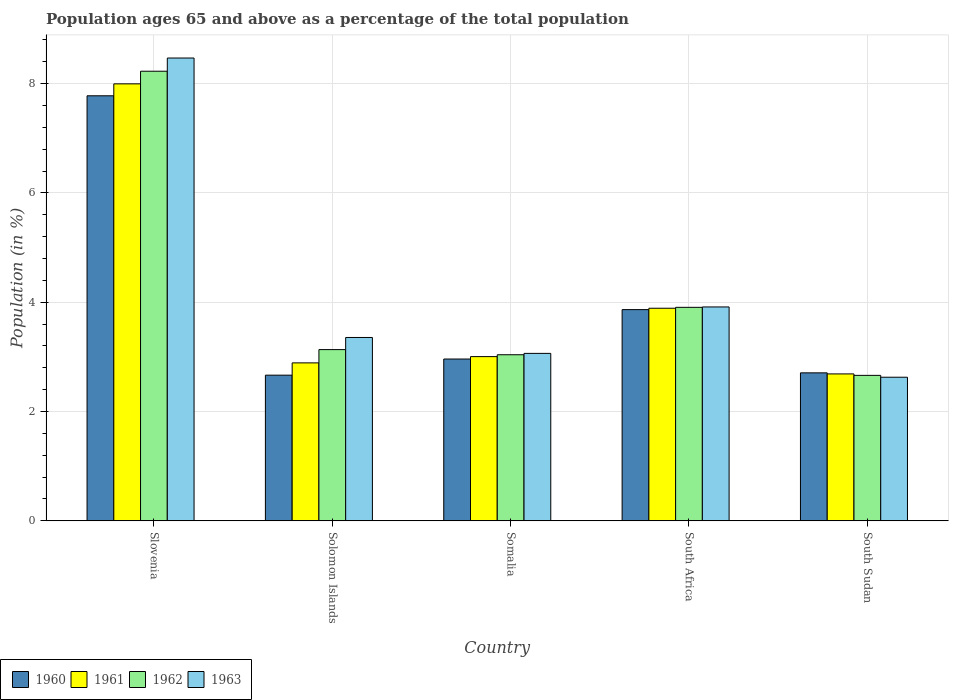How many different coloured bars are there?
Offer a terse response. 4. How many groups of bars are there?
Ensure brevity in your answer.  5. How many bars are there on the 5th tick from the right?
Offer a terse response. 4. What is the label of the 3rd group of bars from the left?
Make the answer very short. Somalia. In how many cases, is the number of bars for a given country not equal to the number of legend labels?
Keep it short and to the point. 0. What is the percentage of the population ages 65 and above in 1960 in Slovenia?
Ensure brevity in your answer.  7.78. Across all countries, what is the maximum percentage of the population ages 65 and above in 1960?
Offer a very short reply. 7.78. Across all countries, what is the minimum percentage of the population ages 65 and above in 1961?
Offer a very short reply. 2.69. In which country was the percentage of the population ages 65 and above in 1961 maximum?
Make the answer very short. Slovenia. In which country was the percentage of the population ages 65 and above in 1963 minimum?
Your response must be concise. South Sudan. What is the total percentage of the population ages 65 and above in 1960 in the graph?
Offer a very short reply. 19.98. What is the difference between the percentage of the population ages 65 and above in 1960 in Solomon Islands and that in South Sudan?
Your answer should be compact. -0.04. What is the difference between the percentage of the population ages 65 and above in 1962 in South Africa and the percentage of the population ages 65 and above in 1961 in South Sudan?
Your answer should be compact. 1.22. What is the average percentage of the population ages 65 and above in 1963 per country?
Make the answer very short. 4.29. What is the difference between the percentage of the population ages 65 and above of/in 1960 and percentage of the population ages 65 and above of/in 1961 in South Africa?
Make the answer very short. -0.03. What is the ratio of the percentage of the population ages 65 and above in 1962 in Somalia to that in South Africa?
Ensure brevity in your answer.  0.78. What is the difference between the highest and the second highest percentage of the population ages 65 and above in 1961?
Your answer should be compact. -0.89. What is the difference between the highest and the lowest percentage of the population ages 65 and above in 1961?
Your response must be concise. 5.31. In how many countries, is the percentage of the population ages 65 and above in 1962 greater than the average percentage of the population ages 65 and above in 1962 taken over all countries?
Make the answer very short. 1. Is the sum of the percentage of the population ages 65 and above in 1960 in Slovenia and Somalia greater than the maximum percentage of the population ages 65 and above in 1961 across all countries?
Your answer should be very brief. Yes. Is it the case that in every country, the sum of the percentage of the population ages 65 and above in 1960 and percentage of the population ages 65 and above in 1961 is greater than the sum of percentage of the population ages 65 and above in 1962 and percentage of the population ages 65 and above in 1963?
Your answer should be compact. No. Is it the case that in every country, the sum of the percentage of the population ages 65 and above in 1961 and percentage of the population ages 65 and above in 1960 is greater than the percentage of the population ages 65 and above in 1962?
Keep it short and to the point. Yes. Are all the bars in the graph horizontal?
Give a very brief answer. No. How many countries are there in the graph?
Give a very brief answer. 5. What is the difference between two consecutive major ticks on the Y-axis?
Offer a terse response. 2. Does the graph contain grids?
Your response must be concise. Yes. How are the legend labels stacked?
Offer a terse response. Horizontal. What is the title of the graph?
Your response must be concise. Population ages 65 and above as a percentage of the total population. Does "1980" appear as one of the legend labels in the graph?
Your response must be concise. No. What is the label or title of the X-axis?
Your answer should be very brief. Country. What is the label or title of the Y-axis?
Ensure brevity in your answer.  Population (in %). What is the Population (in %) in 1960 in Slovenia?
Your response must be concise. 7.78. What is the Population (in %) in 1961 in Slovenia?
Give a very brief answer. 8. What is the Population (in %) of 1962 in Slovenia?
Provide a succinct answer. 8.23. What is the Population (in %) of 1963 in Slovenia?
Give a very brief answer. 8.47. What is the Population (in %) in 1960 in Solomon Islands?
Ensure brevity in your answer.  2.67. What is the Population (in %) in 1961 in Solomon Islands?
Keep it short and to the point. 2.89. What is the Population (in %) in 1962 in Solomon Islands?
Your answer should be very brief. 3.13. What is the Population (in %) of 1963 in Solomon Islands?
Your answer should be compact. 3.36. What is the Population (in %) of 1960 in Somalia?
Provide a succinct answer. 2.96. What is the Population (in %) of 1961 in Somalia?
Your answer should be compact. 3.01. What is the Population (in %) of 1962 in Somalia?
Offer a terse response. 3.04. What is the Population (in %) of 1963 in Somalia?
Ensure brevity in your answer.  3.06. What is the Population (in %) of 1960 in South Africa?
Make the answer very short. 3.87. What is the Population (in %) of 1961 in South Africa?
Keep it short and to the point. 3.89. What is the Population (in %) of 1962 in South Africa?
Provide a short and direct response. 3.91. What is the Population (in %) in 1963 in South Africa?
Ensure brevity in your answer.  3.91. What is the Population (in %) of 1960 in South Sudan?
Your answer should be compact. 2.71. What is the Population (in %) of 1961 in South Sudan?
Provide a short and direct response. 2.69. What is the Population (in %) of 1962 in South Sudan?
Your answer should be very brief. 2.66. What is the Population (in %) of 1963 in South Sudan?
Provide a succinct answer. 2.63. Across all countries, what is the maximum Population (in %) in 1960?
Offer a very short reply. 7.78. Across all countries, what is the maximum Population (in %) of 1961?
Provide a succinct answer. 8. Across all countries, what is the maximum Population (in %) of 1962?
Offer a terse response. 8.23. Across all countries, what is the maximum Population (in %) of 1963?
Make the answer very short. 8.47. Across all countries, what is the minimum Population (in %) in 1960?
Offer a very short reply. 2.67. Across all countries, what is the minimum Population (in %) of 1961?
Keep it short and to the point. 2.69. Across all countries, what is the minimum Population (in %) in 1962?
Provide a succinct answer. 2.66. Across all countries, what is the minimum Population (in %) of 1963?
Keep it short and to the point. 2.63. What is the total Population (in %) of 1960 in the graph?
Provide a short and direct response. 19.98. What is the total Population (in %) in 1961 in the graph?
Provide a succinct answer. 20.47. What is the total Population (in %) in 1962 in the graph?
Your answer should be very brief. 20.97. What is the total Population (in %) in 1963 in the graph?
Make the answer very short. 21.43. What is the difference between the Population (in %) in 1960 in Slovenia and that in Solomon Islands?
Your answer should be very brief. 5.11. What is the difference between the Population (in %) of 1961 in Slovenia and that in Solomon Islands?
Ensure brevity in your answer.  5.11. What is the difference between the Population (in %) of 1962 in Slovenia and that in Solomon Islands?
Provide a short and direct response. 5.09. What is the difference between the Population (in %) of 1963 in Slovenia and that in Solomon Islands?
Your answer should be very brief. 5.11. What is the difference between the Population (in %) of 1960 in Slovenia and that in Somalia?
Give a very brief answer. 4.82. What is the difference between the Population (in %) of 1961 in Slovenia and that in Somalia?
Your answer should be compact. 4.99. What is the difference between the Population (in %) in 1962 in Slovenia and that in Somalia?
Your response must be concise. 5.19. What is the difference between the Population (in %) of 1963 in Slovenia and that in Somalia?
Your answer should be very brief. 5.41. What is the difference between the Population (in %) in 1960 in Slovenia and that in South Africa?
Make the answer very short. 3.91. What is the difference between the Population (in %) of 1961 in Slovenia and that in South Africa?
Make the answer very short. 4.11. What is the difference between the Population (in %) in 1962 in Slovenia and that in South Africa?
Keep it short and to the point. 4.32. What is the difference between the Population (in %) of 1963 in Slovenia and that in South Africa?
Make the answer very short. 4.56. What is the difference between the Population (in %) in 1960 in Slovenia and that in South Sudan?
Give a very brief answer. 5.07. What is the difference between the Population (in %) of 1961 in Slovenia and that in South Sudan?
Your response must be concise. 5.31. What is the difference between the Population (in %) in 1962 in Slovenia and that in South Sudan?
Your response must be concise. 5.57. What is the difference between the Population (in %) in 1963 in Slovenia and that in South Sudan?
Make the answer very short. 5.84. What is the difference between the Population (in %) of 1960 in Solomon Islands and that in Somalia?
Keep it short and to the point. -0.3. What is the difference between the Population (in %) of 1961 in Solomon Islands and that in Somalia?
Your answer should be very brief. -0.11. What is the difference between the Population (in %) in 1962 in Solomon Islands and that in Somalia?
Provide a succinct answer. 0.09. What is the difference between the Population (in %) of 1963 in Solomon Islands and that in Somalia?
Provide a short and direct response. 0.29. What is the difference between the Population (in %) in 1960 in Solomon Islands and that in South Africa?
Give a very brief answer. -1.2. What is the difference between the Population (in %) in 1961 in Solomon Islands and that in South Africa?
Your answer should be compact. -1. What is the difference between the Population (in %) of 1962 in Solomon Islands and that in South Africa?
Offer a very short reply. -0.77. What is the difference between the Population (in %) of 1963 in Solomon Islands and that in South Africa?
Make the answer very short. -0.56. What is the difference between the Population (in %) in 1960 in Solomon Islands and that in South Sudan?
Your response must be concise. -0.04. What is the difference between the Population (in %) in 1961 in Solomon Islands and that in South Sudan?
Offer a terse response. 0.2. What is the difference between the Population (in %) in 1962 in Solomon Islands and that in South Sudan?
Offer a very short reply. 0.47. What is the difference between the Population (in %) of 1963 in Solomon Islands and that in South Sudan?
Offer a very short reply. 0.73. What is the difference between the Population (in %) in 1960 in Somalia and that in South Africa?
Your response must be concise. -0.9. What is the difference between the Population (in %) in 1961 in Somalia and that in South Africa?
Your answer should be very brief. -0.89. What is the difference between the Population (in %) in 1962 in Somalia and that in South Africa?
Your response must be concise. -0.87. What is the difference between the Population (in %) of 1963 in Somalia and that in South Africa?
Your response must be concise. -0.85. What is the difference between the Population (in %) of 1960 in Somalia and that in South Sudan?
Your answer should be compact. 0.25. What is the difference between the Population (in %) of 1961 in Somalia and that in South Sudan?
Give a very brief answer. 0.32. What is the difference between the Population (in %) of 1962 in Somalia and that in South Sudan?
Your answer should be very brief. 0.38. What is the difference between the Population (in %) in 1963 in Somalia and that in South Sudan?
Offer a terse response. 0.44. What is the difference between the Population (in %) in 1960 in South Africa and that in South Sudan?
Ensure brevity in your answer.  1.16. What is the difference between the Population (in %) in 1961 in South Africa and that in South Sudan?
Your response must be concise. 1.2. What is the difference between the Population (in %) in 1962 in South Africa and that in South Sudan?
Make the answer very short. 1.24. What is the difference between the Population (in %) in 1963 in South Africa and that in South Sudan?
Your response must be concise. 1.29. What is the difference between the Population (in %) in 1960 in Slovenia and the Population (in %) in 1961 in Solomon Islands?
Your answer should be very brief. 4.89. What is the difference between the Population (in %) of 1960 in Slovenia and the Population (in %) of 1962 in Solomon Islands?
Ensure brevity in your answer.  4.64. What is the difference between the Population (in %) in 1960 in Slovenia and the Population (in %) in 1963 in Solomon Islands?
Provide a succinct answer. 4.42. What is the difference between the Population (in %) in 1961 in Slovenia and the Population (in %) in 1962 in Solomon Islands?
Offer a terse response. 4.86. What is the difference between the Population (in %) in 1961 in Slovenia and the Population (in %) in 1963 in Solomon Islands?
Your response must be concise. 4.64. What is the difference between the Population (in %) of 1962 in Slovenia and the Population (in %) of 1963 in Solomon Islands?
Keep it short and to the point. 4.87. What is the difference between the Population (in %) of 1960 in Slovenia and the Population (in %) of 1961 in Somalia?
Provide a succinct answer. 4.77. What is the difference between the Population (in %) of 1960 in Slovenia and the Population (in %) of 1962 in Somalia?
Your response must be concise. 4.74. What is the difference between the Population (in %) in 1960 in Slovenia and the Population (in %) in 1963 in Somalia?
Provide a short and direct response. 4.71. What is the difference between the Population (in %) in 1961 in Slovenia and the Population (in %) in 1962 in Somalia?
Ensure brevity in your answer.  4.96. What is the difference between the Population (in %) in 1961 in Slovenia and the Population (in %) in 1963 in Somalia?
Ensure brevity in your answer.  4.93. What is the difference between the Population (in %) in 1962 in Slovenia and the Population (in %) in 1963 in Somalia?
Keep it short and to the point. 5.16. What is the difference between the Population (in %) in 1960 in Slovenia and the Population (in %) in 1961 in South Africa?
Provide a succinct answer. 3.89. What is the difference between the Population (in %) in 1960 in Slovenia and the Population (in %) in 1962 in South Africa?
Your response must be concise. 3.87. What is the difference between the Population (in %) in 1960 in Slovenia and the Population (in %) in 1963 in South Africa?
Provide a succinct answer. 3.86. What is the difference between the Population (in %) of 1961 in Slovenia and the Population (in %) of 1962 in South Africa?
Offer a very short reply. 4.09. What is the difference between the Population (in %) in 1961 in Slovenia and the Population (in %) in 1963 in South Africa?
Make the answer very short. 4.08. What is the difference between the Population (in %) in 1962 in Slovenia and the Population (in %) in 1963 in South Africa?
Ensure brevity in your answer.  4.31. What is the difference between the Population (in %) in 1960 in Slovenia and the Population (in %) in 1961 in South Sudan?
Offer a very short reply. 5.09. What is the difference between the Population (in %) in 1960 in Slovenia and the Population (in %) in 1962 in South Sudan?
Keep it short and to the point. 5.12. What is the difference between the Population (in %) in 1960 in Slovenia and the Population (in %) in 1963 in South Sudan?
Your answer should be very brief. 5.15. What is the difference between the Population (in %) of 1961 in Slovenia and the Population (in %) of 1962 in South Sudan?
Offer a very short reply. 5.33. What is the difference between the Population (in %) in 1961 in Slovenia and the Population (in %) in 1963 in South Sudan?
Provide a short and direct response. 5.37. What is the difference between the Population (in %) in 1962 in Slovenia and the Population (in %) in 1963 in South Sudan?
Ensure brevity in your answer.  5.6. What is the difference between the Population (in %) of 1960 in Solomon Islands and the Population (in %) of 1961 in Somalia?
Provide a succinct answer. -0.34. What is the difference between the Population (in %) in 1960 in Solomon Islands and the Population (in %) in 1962 in Somalia?
Offer a terse response. -0.37. What is the difference between the Population (in %) in 1960 in Solomon Islands and the Population (in %) in 1963 in Somalia?
Make the answer very short. -0.4. What is the difference between the Population (in %) in 1961 in Solomon Islands and the Population (in %) in 1962 in Somalia?
Keep it short and to the point. -0.15. What is the difference between the Population (in %) in 1961 in Solomon Islands and the Population (in %) in 1963 in Somalia?
Make the answer very short. -0.17. What is the difference between the Population (in %) in 1962 in Solomon Islands and the Population (in %) in 1963 in Somalia?
Ensure brevity in your answer.  0.07. What is the difference between the Population (in %) in 1960 in Solomon Islands and the Population (in %) in 1961 in South Africa?
Ensure brevity in your answer.  -1.22. What is the difference between the Population (in %) of 1960 in Solomon Islands and the Population (in %) of 1962 in South Africa?
Keep it short and to the point. -1.24. What is the difference between the Population (in %) in 1960 in Solomon Islands and the Population (in %) in 1963 in South Africa?
Ensure brevity in your answer.  -1.25. What is the difference between the Population (in %) of 1961 in Solomon Islands and the Population (in %) of 1962 in South Africa?
Offer a very short reply. -1.02. What is the difference between the Population (in %) of 1961 in Solomon Islands and the Population (in %) of 1963 in South Africa?
Ensure brevity in your answer.  -1.02. What is the difference between the Population (in %) of 1962 in Solomon Islands and the Population (in %) of 1963 in South Africa?
Make the answer very short. -0.78. What is the difference between the Population (in %) of 1960 in Solomon Islands and the Population (in %) of 1961 in South Sudan?
Offer a terse response. -0.02. What is the difference between the Population (in %) of 1960 in Solomon Islands and the Population (in %) of 1962 in South Sudan?
Provide a succinct answer. 0. What is the difference between the Population (in %) in 1960 in Solomon Islands and the Population (in %) in 1963 in South Sudan?
Give a very brief answer. 0.04. What is the difference between the Population (in %) of 1961 in Solomon Islands and the Population (in %) of 1962 in South Sudan?
Offer a terse response. 0.23. What is the difference between the Population (in %) of 1961 in Solomon Islands and the Population (in %) of 1963 in South Sudan?
Ensure brevity in your answer.  0.26. What is the difference between the Population (in %) in 1962 in Solomon Islands and the Population (in %) in 1963 in South Sudan?
Keep it short and to the point. 0.51. What is the difference between the Population (in %) of 1960 in Somalia and the Population (in %) of 1961 in South Africa?
Provide a short and direct response. -0.93. What is the difference between the Population (in %) of 1960 in Somalia and the Population (in %) of 1962 in South Africa?
Give a very brief answer. -0.95. What is the difference between the Population (in %) in 1960 in Somalia and the Population (in %) in 1963 in South Africa?
Your response must be concise. -0.95. What is the difference between the Population (in %) of 1961 in Somalia and the Population (in %) of 1962 in South Africa?
Your answer should be compact. -0.9. What is the difference between the Population (in %) in 1961 in Somalia and the Population (in %) in 1963 in South Africa?
Your response must be concise. -0.91. What is the difference between the Population (in %) in 1962 in Somalia and the Population (in %) in 1963 in South Africa?
Offer a very short reply. -0.87. What is the difference between the Population (in %) in 1960 in Somalia and the Population (in %) in 1961 in South Sudan?
Your answer should be compact. 0.27. What is the difference between the Population (in %) in 1960 in Somalia and the Population (in %) in 1962 in South Sudan?
Your answer should be very brief. 0.3. What is the difference between the Population (in %) of 1960 in Somalia and the Population (in %) of 1963 in South Sudan?
Offer a terse response. 0.33. What is the difference between the Population (in %) of 1961 in Somalia and the Population (in %) of 1962 in South Sudan?
Make the answer very short. 0.34. What is the difference between the Population (in %) in 1961 in Somalia and the Population (in %) in 1963 in South Sudan?
Your answer should be very brief. 0.38. What is the difference between the Population (in %) of 1962 in Somalia and the Population (in %) of 1963 in South Sudan?
Ensure brevity in your answer.  0.41. What is the difference between the Population (in %) in 1960 in South Africa and the Population (in %) in 1961 in South Sudan?
Offer a very short reply. 1.18. What is the difference between the Population (in %) of 1960 in South Africa and the Population (in %) of 1962 in South Sudan?
Provide a succinct answer. 1.2. What is the difference between the Population (in %) in 1960 in South Africa and the Population (in %) in 1963 in South Sudan?
Provide a succinct answer. 1.24. What is the difference between the Population (in %) of 1961 in South Africa and the Population (in %) of 1962 in South Sudan?
Your response must be concise. 1.23. What is the difference between the Population (in %) in 1961 in South Africa and the Population (in %) in 1963 in South Sudan?
Provide a succinct answer. 1.26. What is the difference between the Population (in %) of 1962 in South Africa and the Population (in %) of 1963 in South Sudan?
Offer a terse response. 1.28. What is the average Population (in %) in 1960 per country?
Give a very brief answer. 4. What is the average Population (in %) of 1961 per country?
Your answer should be very brief. 4.09. What is the average Population (in %) in 1962 per country?
Offer a terse response. 4.19. What is the average Population (in %) of 1963 per country?
Make the answer very short. 4.29. What is the difference between the Population (in %) in 1960 and Population (in %) in 1961 in Slovenia?
Ensure brevity in your answer.  -0.22. What is the difference between the Population (in %) in 1960 and Population (in %) in 1962 in Slovenia?
Give a very brief answer. -0.45. What is the difference between the Population (in %) in 1960 and Population (in %) in 1963 in Slovenia?
Offer a terse response. -0.69. What is the difference between the Population (in %) of 1961 and Population (in %) of 1962 in Slovenia?
Your answer should be compact. -0.23. What is the difference between the Population (in %) in 1961 and Population (in %) in 1963 in Slovenia?
Give a very brief answer. -0.47. What is the difference between the Population (in %) of 1962 and Population (in %) of 1963 in Slovenia?
Offer a terse response. -0.24. What is the difference between the Population (in %) in 1960 and Population (in %) in 1961 in Solomon Islands?
Your response must be concise. -0.22. What is the difference between the Population (in %) of 1960 and Population (in %) of 1962 in Solomon Islands?
Your answer should be compact. -0.47. What is the difference between the Population (in %) in 1960 and Population (in %) in 1963 in Solomon Islands?
Provide a succinct answer. -0.69. What is the difference between the Population (in %) of 1961 and Population (in %) of 1962 in Solomon Islands?
Your answer should be very brief. -0.24. What is the difference between the Population (in %) of 1961 and Population (in %) of 1963 in Solomon Islands?
Offer a very short reply. -0.47. What is the difference between the Population (in %) in 1962 and Population (in %) in 1963 in Solomon Islands?
Provide a short and direct response. -0.22. What is the difference between the Population (in %) in 1960 and Population (in %) in 1961 in Somalia?
Provide a short and direct response. -0.04. What is the difference between the Population (in %) in 1960 and Population (in %) in 1962 in Somalia?
Provide a succinct answer. -0.08. What is the difference between the Population (in %) in 1960 and Population (in %) in 1963 in Somalia?
Keep it short and to the point. -0.1. What is the difference between the Population (in %) of 1961 and Population (in %) of 1962 in Somalia?
Give a very brief answer. -0.03. What is the difference between the Population (in %) in 1961 and Population (in %) in 1963 in Somalia?
Provide a succinct answer. -0.06. What is the difference between the Population (in %) of 1962 and Population (in %) of 1963 in Somalia?
Make the answer very short. -0.02. What is the difference between the Population (in %) of 1960 and Population (in %) of 1961 in South Africa?
Make the answer very short. -0.03. What is the difference between the Population (in %) of 1960 and Population (in %) of 1962 in South Africa?
Provide a short and direct response. -0.04. What is the difference between the Population (in %) of 1960 and Population (in %) of 1963 in South Africa?
Your response must be concise. -0.05. What is the difference between the Population (in %) of 1961 and Population (in %) of 1962 in South Africa?
Offer a very short reply. -0.02. What is the difference between the Population (in %) of 1961 and Population (in %) of 1963 in South Africa?
Give a very brief answer. -0.02. What is the difference between the Population (in %) in 1962 and Population (in %) in 1963 in South Africa?
Your answer should be very brief. -0.01. What is the difference between the Population (in %) in 1960 and Population (in %) in 1961 in South Sudan?
Your answer should be compact. 0.02. What is the difference between the Population (in %) in 1960 and Population (in %) in 1962 in South Sudan?
Offer a terse response. 0.05. What is the difference between the Population (in %) of 1960 and Population (in %) of 1963 in South Sudan?
Your answer should be compact. 0.08. What is the difference between the Population (in %) in 1961 and Population (in %) in 1962 in South Sudan?
Give a very brief answer. 0.03. What is the difference between the Population (in %) in 1961 and Population (in %) in 1963 in South Sudan?
Provide a succinct answer. 0.06. What is the difference between the Population (in %) of 1962 and Population (in %) of 1963 in South Sudan?
Your answer should be very brief. 0.03. What is the ratio of the Population (in %) of 1960 in Slovenia to that in Solomon Islands?
Offer a terse response. 2.92. What is the ratio of the Population (in %) in 1961 in Slovenia to that in Solomon Islands?
Offer a very short reply. 2.77. What is the ratio of the Population (in %) in 1962 in Slovenia to that in Solomon Islands?
Provide a short and direct response. 2.63. What is the ratio of the Population (in %) in 1963 in Slovenia to that in Solomon Islands?
Ensure brevity in your answer.  2.52. What is the ratio of the Population (in %) of 1960 in Slovenia to that in Somalia?
Your answer should be compact. 2.63. What is the ratio of the Population (in %) in 1961 in Slovenia to that in Somalia?
Offer a very short reply. 2.66. What is the ratio of the Population (in %) in 1962 in Slovenia to that in Somalia?
Provide a succinct answer. 2.71. What is the ratio of the Population (in %) in 1963 in Slovenia to that in Somalia?
Provide a short and direct response. 2.76. What is the ratio of the Population (in %) in 1960 in Slovenia to that in South Africa?
Offer a terse response. 2.01. What is the ratio of the Population (in %) of 1961 in Slovenia to that in South Africa?
Ensure brevity in your answer.  2.06. What is the ratio of the Population (in %) of 1962 in Slovenia to that in South Africa?
Ensure brevity in your answer.  2.11. What is the ratio of the Population (in %) in 1963 in Slovenia to that in South Africa?
Make the answer very short. 2.16. What is the ratio of the Population (in %) of 1960 in Slovenia to that in South Sudan?
Offer a very short reply. 2.87. What is the ratio of the Population (in %) in 1961 in Slovenia to that in South Sudan?
Your answer should be very brief. 2.97. What is the ratio of the Population (in %) of 1962 in Slovenia to that in South Sudan?
Offer a terse response. 3.09. What is the ratio of the Population (in %) in 1963 in Slovenia to that in South Sudan?
Make the answer very short. 3.22. What is the ratio of the Population (in %) in 1960 in Solomon Islands to that in Somalia?
Your response must be concise. 0.9. What is the ratio of the Population (in %) in 1961 in Solomon Islands to that in Somalia?
Offer a very short reply. 0.96. What is the ratio of the Population (in %) of 1962 in Solomon Islands to that in Somalia?
Provide a short and direct response. 1.03. What is the ratio of the Population (in %) of 1963 in Solomon Islands to that in Somalia?
Ensure brevity in your answer.  1.1. What is the ratio of the Population (in %) of 1960 in Solomon Islands to that in South Africa?
Ensure brevity in your answer.  0.69. What is the ratio of the Population (in %) of 1961 in Solomon Islands to that in South Africa?
Your answer should be very brief. 0.74. What is the ratio of the Population (in %) in 1962 in Solomon Islands to that in South Africa?
Give a very brief answer. 0.8. What is the ratio of the Population (in %) of 1963 in Solomon Islands to that in South Africa?
Your response must be concise. 0.86. What is the ratio of the Population (in %) in 1960 in Solomon Islands to that in South Sudan?
Provide a succinct answer. 0.98. What is the ratio of the Population (in %) of 1961 in Solomon Islands to that in South Sudan?
Your answer should be very brief. 1.08. What is the ratio of the Population (in %) of 1962 in Solomon Islands to that in South Sudan?
Offer a very short reply. 1.18. What is the ratio of the Population (in %) of 1963 in Solomon Islands to that in South Sudan?
Ensure brevity in your answer.  1.28. What is the ratio of the Population (in %) in 1960 in Somalia to that in South Africa?
Keep it short and to the point. 0.77. What is the ratio of the Population (in %) in 1961 in Somalia to that in South Africa?
Provide a succinct answer. 0.77. What is the ratio of the Population (in %) in 1962 in Somalia to that in South Africa?
Your answer should be compact. 0.78. What is the ratio of the Population (in %) of 1963 in Somalia to that in South Africa?
Your answer should be very brief. 0.78. What is the ratio of the Population (in %) of 1960 in Somalia to that in South Sudan?
Provide a succinct answer. 1.09. What is the ratio of the Population (in %) in 1961 in Somalia to that in South Sudan?
Give a very brief answer. 1.12. What is the ratio of the Population (in %) in 1962 in Somalia to that in South Sudan?
Make the answer very short. 1.14. What is the ratio of the Population (in %) of 1963 in Somalia to that in South Sudan?
Give a very brief answer. 1.17. What is the ratio of the Population (in %) in 1960 in South Africa to that in South Sudan?
Provide a succinct answer. 1.43. What is the ratio of the Population (in %) of 1961 in South Africa to that in South Sudan?
Provide a succinct answer. 1.45. What is the ratio of the Population (in %) in 1962 in South Africa to that in South Sudan?
Provide a succinct answer. 1.47. What is the ratio of the Population (in %) of 1963 in South Africa to that in South Sudan?
Your answer should be compact. 1.49. What is the difference between the highest and the second highest Population (in %) in 1960?
Give a very brief answer. 3.91. What is the difference between the highest and the second highest Population (in %) in 1961?
Provide a succinct answer. 4.11. What is the difference between the highest and the second highest Population (in %) in 1962?
Offer a terse response. 4.32. What is the difference between the highest and the second highest Population (in %) in 1963?
Offer a very short reply. 4.56. What is the difference between the highest and the lowest Population (in %) in 1960?
Provide a succinct answer. 5.11. What is the difference between the highest and the lowest Population (in %) in 1961?
Give a very brief answer. 5.31. What is the difference between the highest and the lowest Population (in %) in 1962?
Ensure brevity in your answer.  5.57. What is the difference between the highest and the lowest Population (in %) of 1963?
Your answer should be compact. 5.84. 